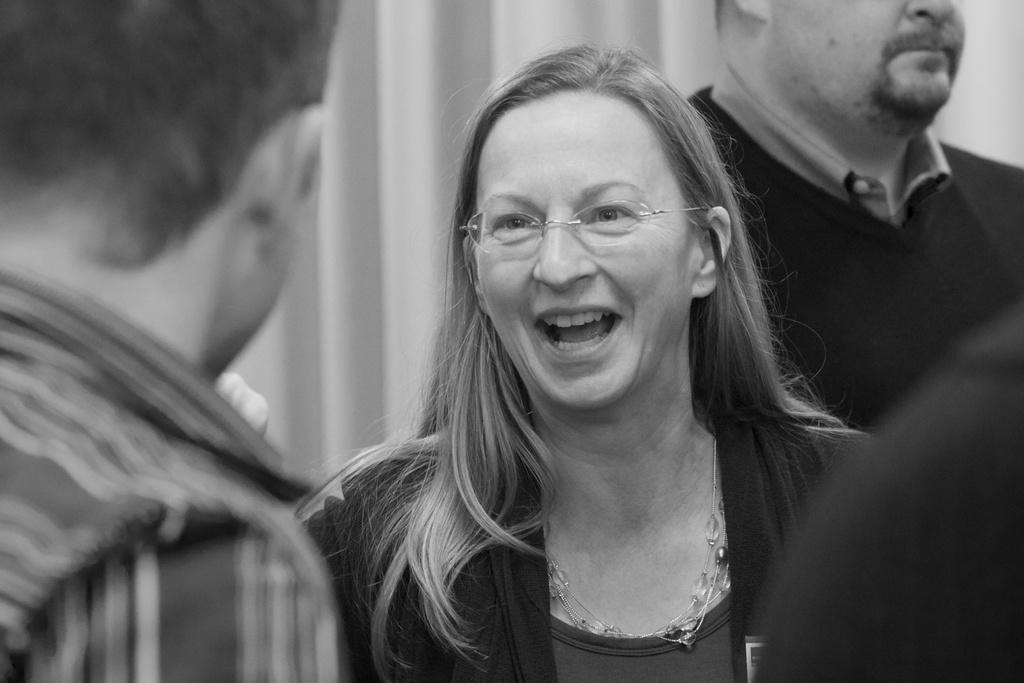Can you describe this image briefly? In this picture we can see a woman smiling and there are two men. 